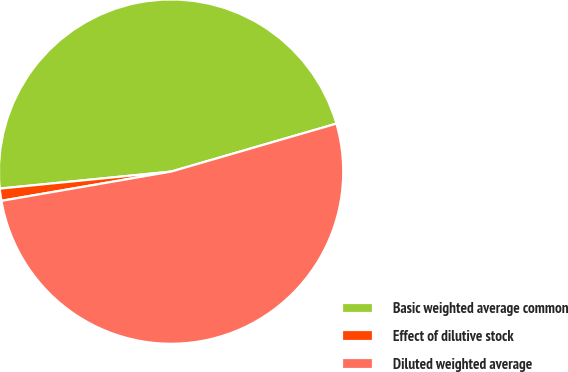Convert chart. <chart><loc_0><loc_0><loc_500><loc_500><pie_chart><fcel>Basic weighted average common<fcel>Effect of dilutive stock<fcel>Diluted weighted average<nl><fcel>47.08%<fcel>1.14%<fcel>51.78%<nl></chart> 